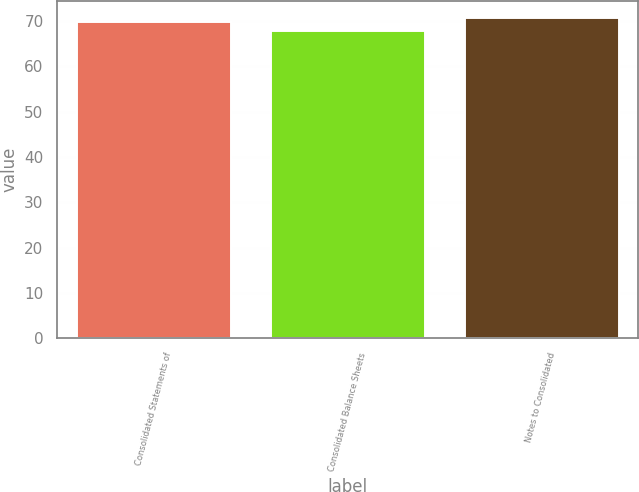Convert chart. <chart><loc_0><loc_0><loc_500><loc_500><bar_chart><fcel>Consolidated Statements of<fcel>Consolidated Balance Sheets<fcel>Notes to Consolidated<nl><fcel>70<fcel>68<fcel>71<nl></chart> 